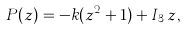<formula> <loc_0><loc_0><loc_500><loc_500>P ( z ) = - k ( z ^ { 2 } + 1 ) + I _ { 3 } \, z ,</formula> 